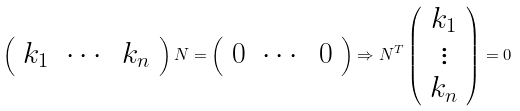<formula> <loc_0><loc_0><loc_500><loc_500>\left ( \begin{array} { c c c } k _ { 1 } & \cdots & k _ { n } \end{array} \right ) N = \left ( \begin{array} { c c c } 0 & \cdots & 0 \end{array} \right ) \Rightarrow N ^ { T } \left ( \begin{array} { c } k _ { 1 } \\ \vdots \\ k _ { n } \end{array} \right ) = 0</formula> 